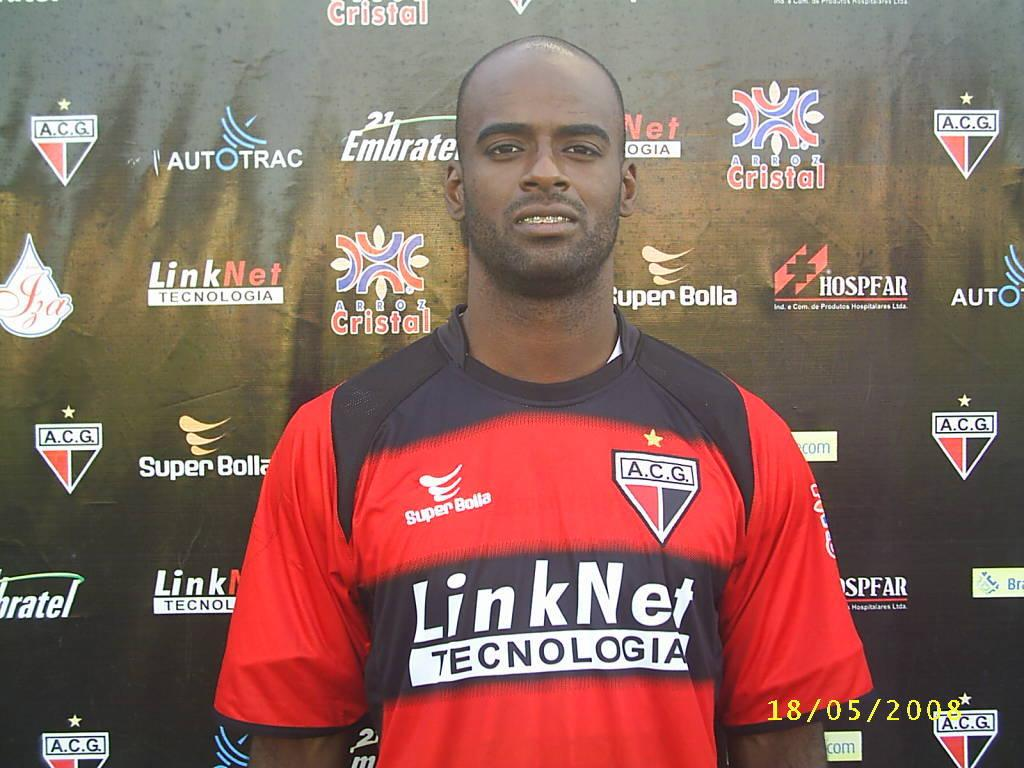<image>
Render a clear and concise summary of the photo. A man wearing a jersey sponsored by LinkNet Tecnologia stands in front of a black wall. 